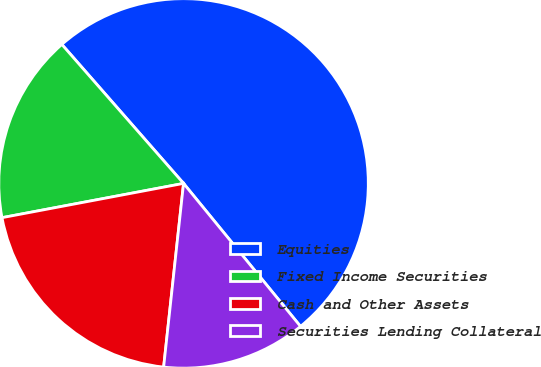Convert chart to OTSL. <chart><loc_0><loc_0><loc_500><loc_500><pie_chart><fcel>Equities<fcel>Fixed Income Securities<fcel>Cash and Other Assets<fcel>Securities Lending Collateral<nl><fcel>50.53%<fcel>16.52%<fcel>20.31%<fcel>12.63%<nl></chart> 